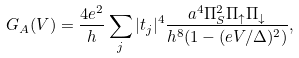<formula> <loc_0><loc_0><loc_500><loc_500>G _ { A } ( V ) = \frac { 4 e ^ { 2 } } { h } \sum _ { j } | t _ { j } | ^ { 4 } \frac { a ^ { 4 } \Pi _ { S } ^ { 2 } \Pi _ { \uparrow } \Pi _ { \downarrow } } { h ^ { 8 } ( 1 - ( e V / \Delta ) ^ { 2 } ) } ,</formula> 